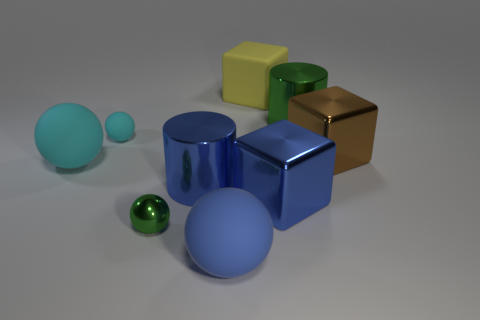Add 1 small shiny spheres. How many objects exist? 10 Subtract all cylinders. How many objects are left? 7 Subtract all small red matte things. Subtract all big blue matte balls. How many objects are left? 8 Add 3 yellow things. How many yellow things are left? 4 Add 4 big metallic things. How many big metallic things exist? 8 Subtract 0 green cubes. How many objects are left? 9 